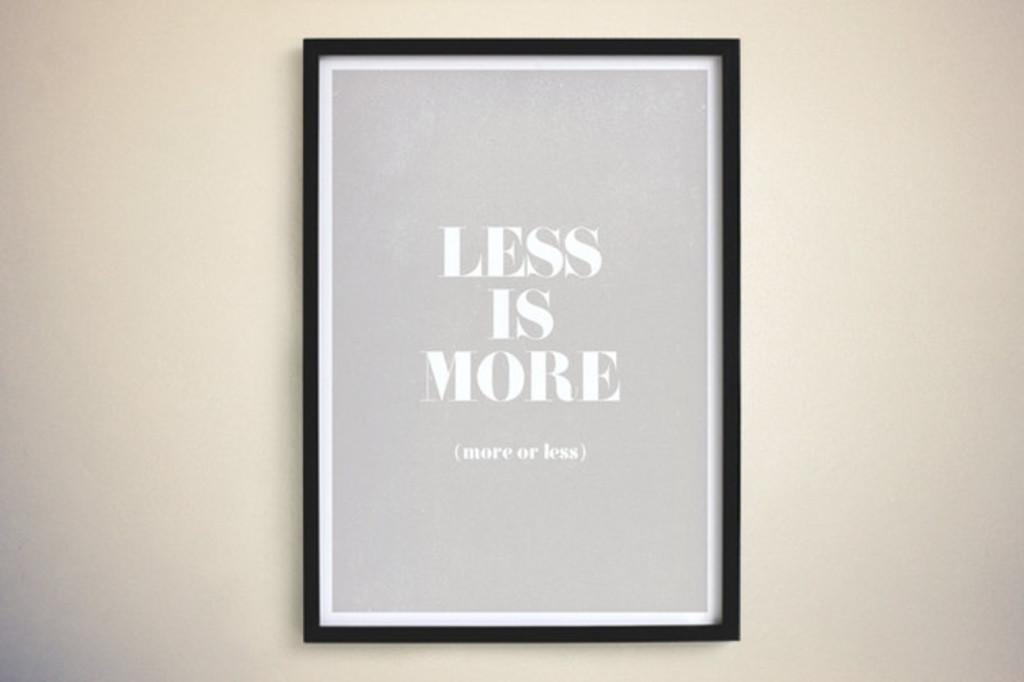<image>
Relay a brief, clear account of the picture shown. a framed paper that says 'less is more' on it 